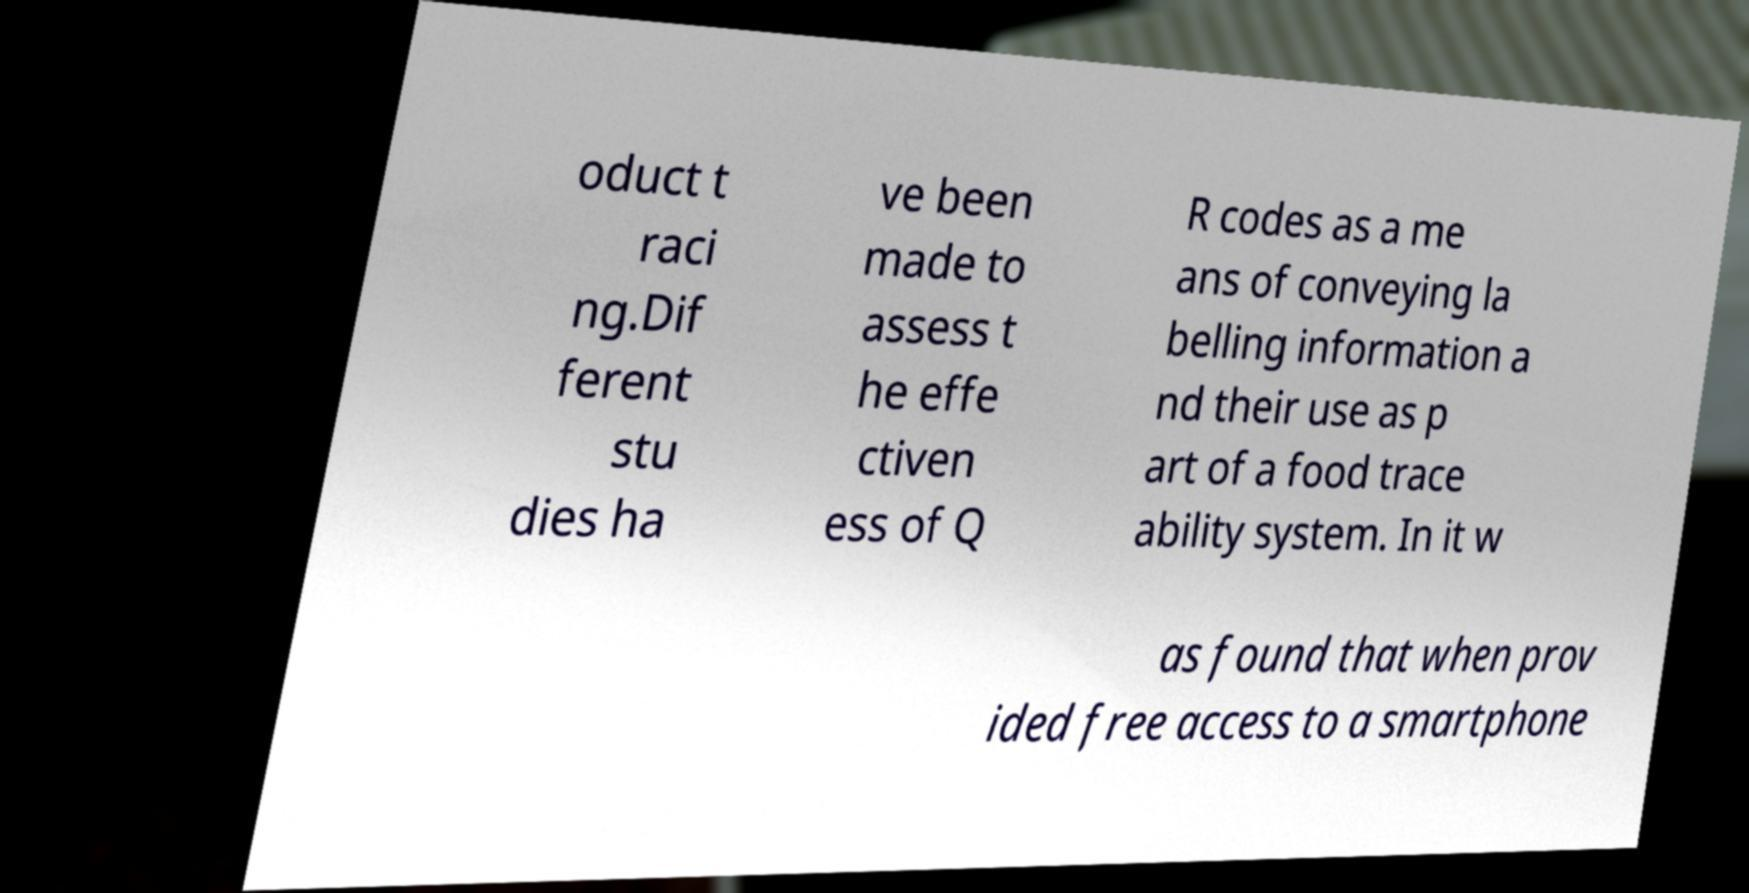There's text embedded in this image that I need extracted. Can you transcribe it verbatim? oduct t raci ng.Dif ferent stu dies ha ve been made to assess t he effe ctiven ess of Q R codes as a me ans of conveying la belling information a nd their use as p art of a food trace ability system. In it w as found that when prov ided free access to a smartphone 